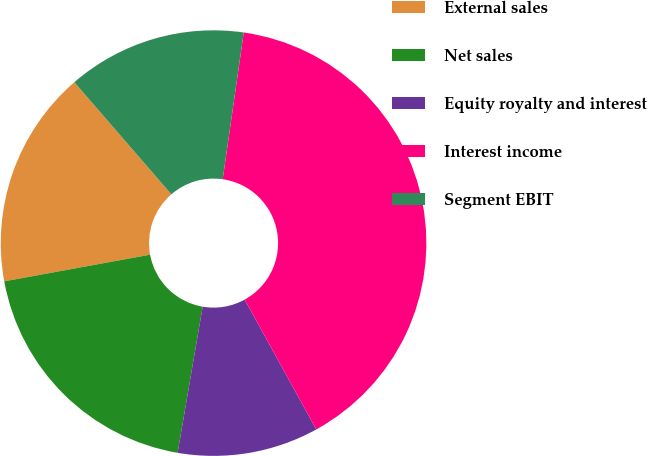<chart> <loc_0><loc_0><loc_500><loc_500><pie_chart><fcel>External sales<fcel>Net sales<fcel>Equity royalty and interest<fcel>Interest income<fcel>Segment EBIT<nl><fcel>16.52%<fcel>19.42%<fcel>10.72%<fcel>39.71%<fcel>13.62%<nl></chart> 